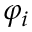<formula> <loc_0><loc_0><loc_500><loc_500>\varphi _ { i }</formula> 